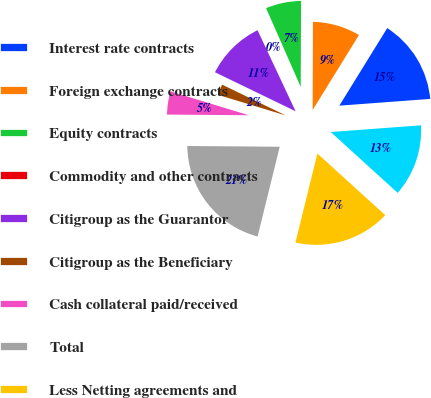Convert chart. <chart><loc_0><loc_0><loc_500><loc_500><pie_chart><fcel>Interest rate contracts<fcel>Foreign exchange contracts<fcel>Equity contracts<fcel>Commodity and other contracts<fcel>Citigroup as the Guarantor<fcel>Citigroup as the Beneficiary<fcel>Cash collateral paid/received<fcel>Total<fcel>Less Netting agreements and<fcel>Net receivables/payables<nl><fcel>15.02%<fcel>8.75%<fcel>6.66%<fcel>0.39%<fcel>10.84%<fcel>2.48%<fcel>4.57%<fcel>21.29%<fcel>17.11%<fcel>12.93%<nl></chart> 